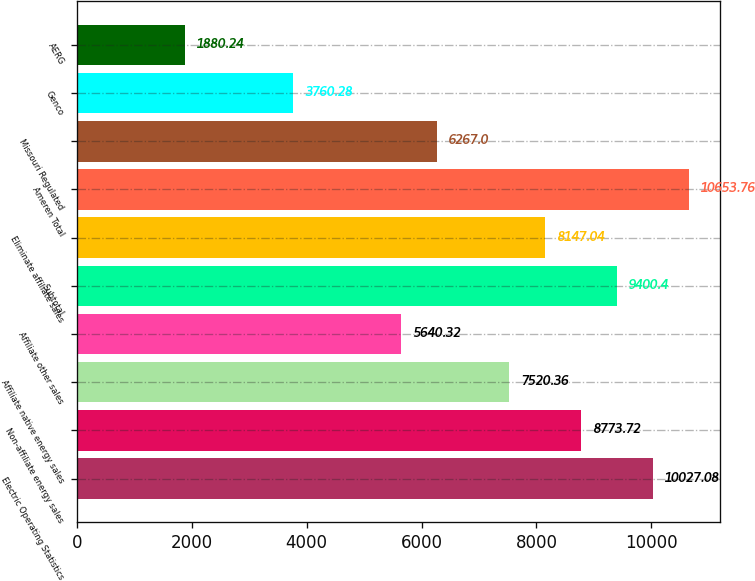Convert chart. <chart><loc_0><loc_0><loc_500><loc_500><bar_chart><fcel>Electric Operating Statistics<fcel>Non-affiliate energy sales<fcel>Affiliate native energy sales<fcel>Affiliate other sales<fcel>Subtotal<fcel>Eliminate affiliate sales<fcel>Ameren Total<fcel>Missouri Regulated<fcel>Genco<fcel>AERG<nl><fcel>10027.1<fcel>8773.72<fcel>7520.36<fcel>5640.32<fcel>9400.4<fcel>8147.04<fcel>10653.8<fcel>6267<fcel>3760.28<fcel>1880.24<nl></chart> 